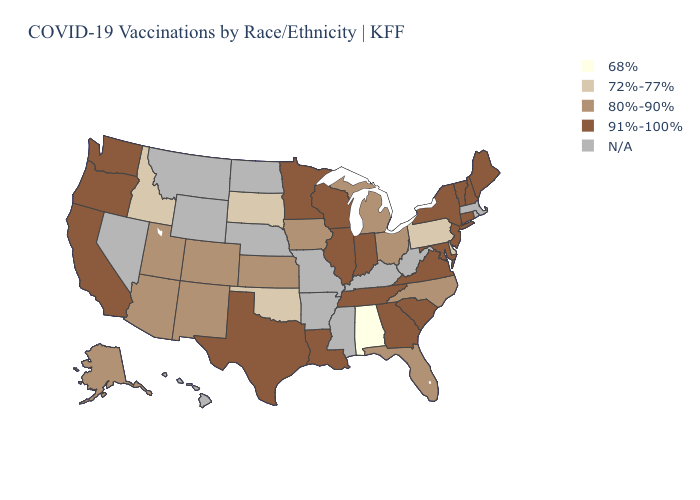Which states hav the highest value in the South?
Write a very short answer. Georgia, Louisiana, Maryland, South Carolina, Tennessee, Texas, Virginia. Name the states that have a value in the range 91%-100%?
Give a very brief answer. California, Connecticut, Georgia, Illinois, Indiana, Louisiana, Maine, Maryland, Minnesota, New Hampshire, New Jersey, New York, Oregon, South Carolina, Tennessee, Texas, Vermont, Virginia, Washington, Wisconsin. Name the states that have a value in the range 91%-100%?
Write a very short answer. California, Connecticut, Georgia, Illinois, Indiana, Louisiana, Maine, Maryland, Minnesota, New Hampshire, New Jersey, New York, Oregon, South Carolina, Tennessee, Texas, Vermont, Virginia, Washington, Wisconsin. What is the value of Kansas?
Short answer required. 80%-90%. What is the value of New York?
Answer briefly. 91%-100%. What is the lowest value in states that border Arizona?
Write a very short answer. 80%-90%. What is the value of Alaska?
Give a very brief answer. 80%-90%. What is the value of Alaska?
Quick response, please. 80%-90%. Among the states that border Georgia , which have the lowest value?
Keep it brief. Alabama. Does Maryland have the lowest value in the South?
Short answer required. No. Name the states that have a value in the range 91%-100%?
Concise answer only. California, Connecticut, Georgia, Illinois, Indiana, Louisiana, Maine, Maryland, Minnesota, New Hampshire, New Jersey, New York, Oregon, South Carolina, Tennessee, Texas, Vermont, Virginia, Washington, Wisconsin. Which states hav the highest value in the South?
Be succinct. Georgia, Louisiana, Maryland, South Carolina, Tennessee, Texas, Virginia. What is the value of Wyoming?
Write a very short answer. N/A. What is the lowest value in the West?
Give a very brief answer. 72%-77%. 